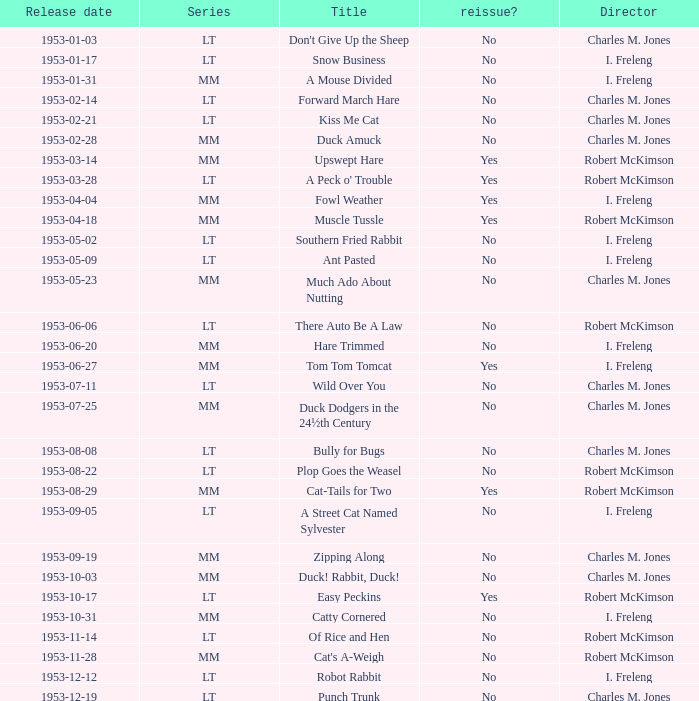What's the title for the release date of 1953-01-31 in the MM series, no reissue, and a director of I. Freleng? A Mouse Divided. 